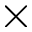Convert formula to latex. <formula><loc_0><loc_0><loc_500><loc_500>\times</formula> 